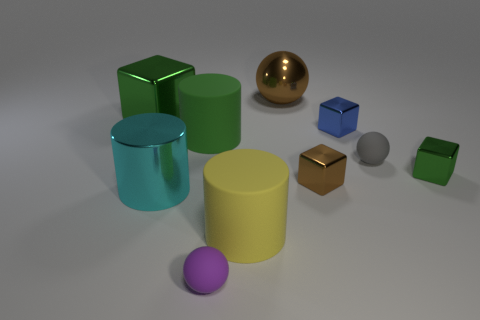How many objects are either large cyan metal objects or matte objects on the right side of the brown cube?
Offer a terse response. 2. There is a small rubber object that is in front of the big metallic cylinder; does it have the same shape as the brown metal object that is to the right of the metallic sphere?
Make the answer very short. No. How many things are yellow matte cylinders or large blue objects?
Your answer should be very brief. 1. Are there any other things that have the same material as the yellow thing?
Provide a succinct answer. Yes. Are any tiny red rubber cubes visible?
Provide a succinct answer. No. Is the small sphere left of the yellow thing made of the same material as the tiny green cube?
Keep it short and to the point. No. Is there a small brown shiny thing of the same shape as the small gray object?
Offer a terse response. No. Are there an equal number of big cyan cylinders that are right of the yellow matte object and big red metal blocks?
Your answer should be compact. Yes. There is a cube that is in front of the green cube right of the small blue metal cube; what is its material?
Your answer should be very brief. Metal. What is the shape of the purple matte thing?
Offer a terse response. Sphere. 